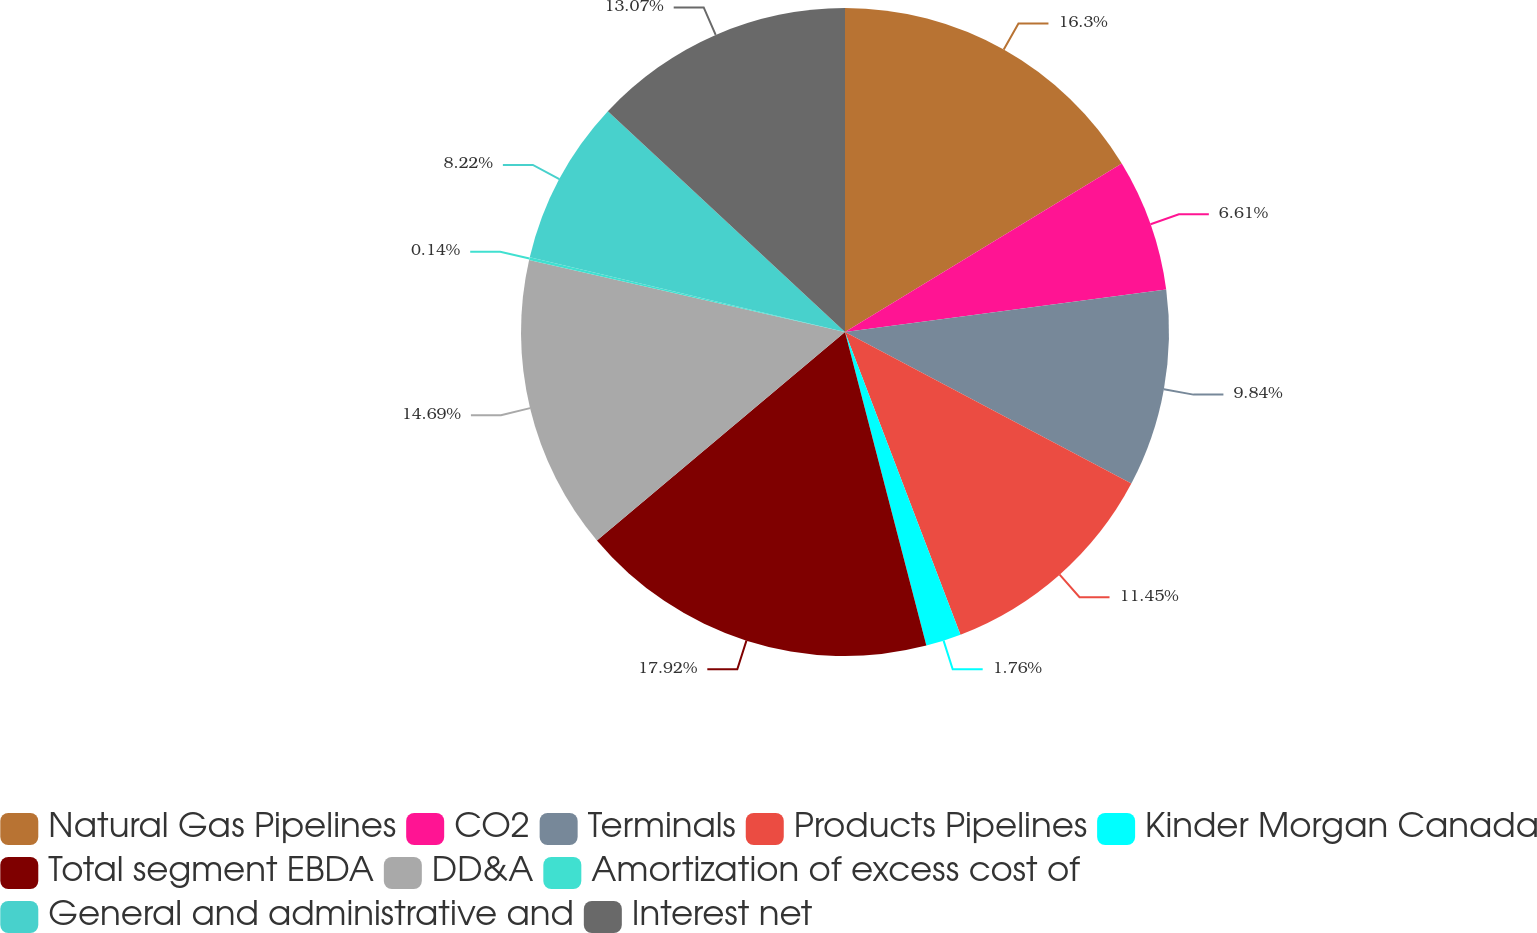<chart> <loc_0><loc_0><loc_500><loc_500><pie_chart><fcel>Natural Gas Pipelines<fcel>CO2<fcel>Terminals<fcel>Products Pipelines<fcel>Kinder Morgan Canada<fcel>Total segment EBDA<fcel>DD&A<fcel>Amortization of excess cost of<fcel>General and administrative and<fcel>Interest net<nl><fcel>16.3%<fcel>6.61%<fcel>9.84%<fcel>11.45%<fcel>1.76%<fcel>17.92%<fcel>14.69%<fcel>0.14%<fcel>8.22%<fcel>13.07%<nl></chart> 